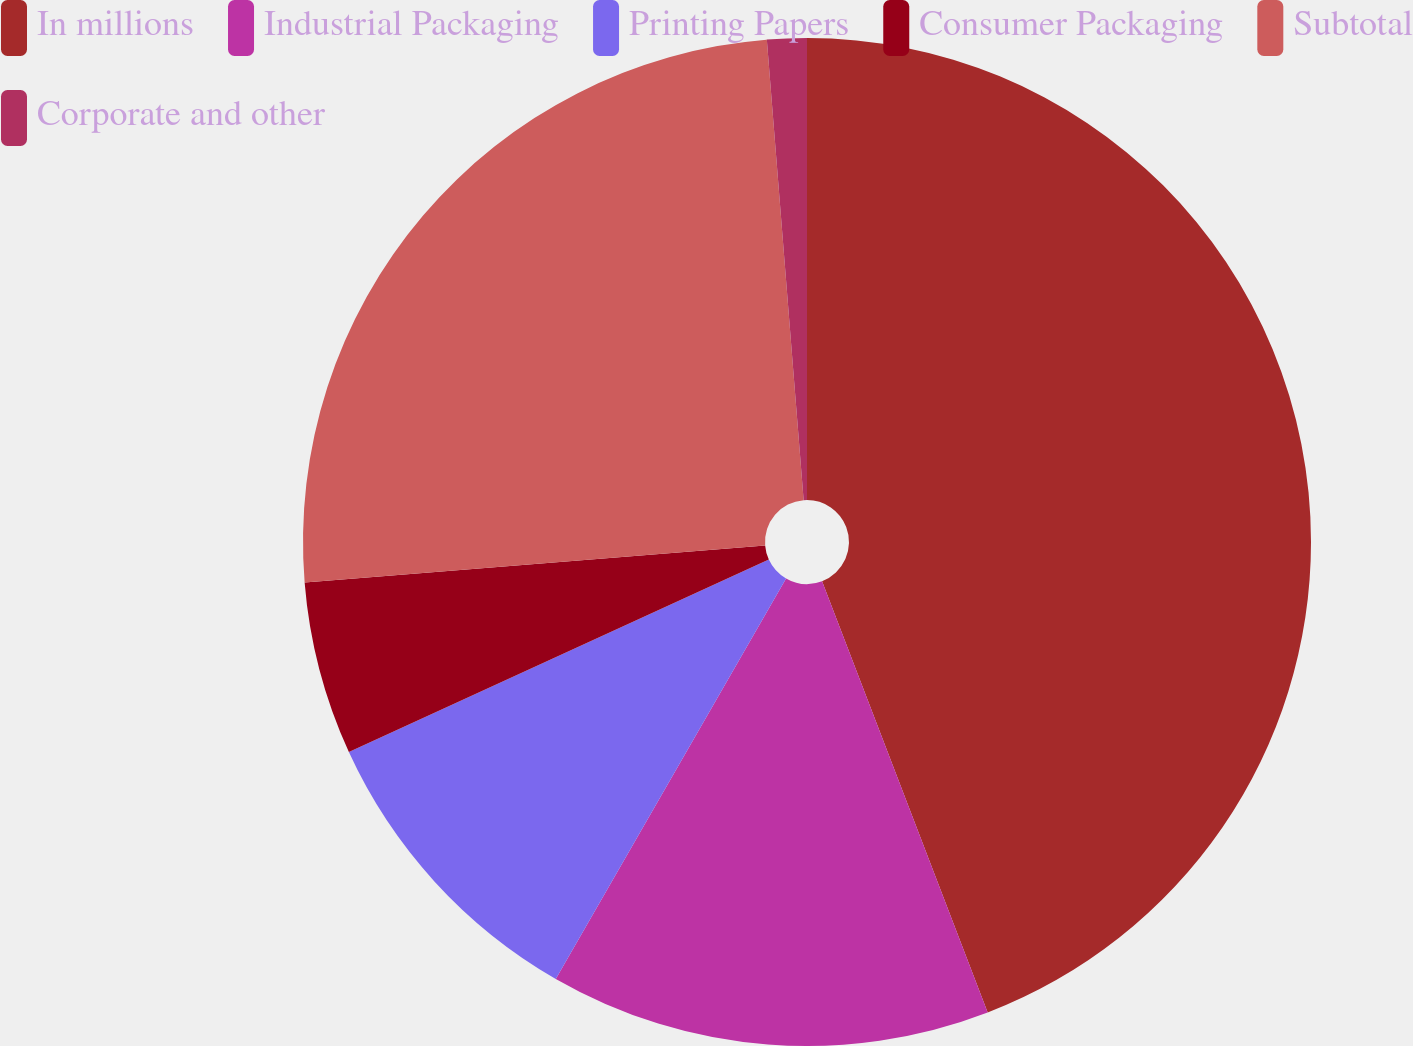<chart> <loc_0><loc_0><loc_500><loc_500><pie_chart><fcel>In millions<fcel>Industrial Packaging<fcel>Printing Papers<fcel>Consumer Packaging<fcel>Subtotal<fcel>Corporate and other<nl><fcel>44.16%<fcel>14.14%<fcel>9.85%<fcel>5.56%<fcel>25.01%<fcel>1.27%<nl></chart> 